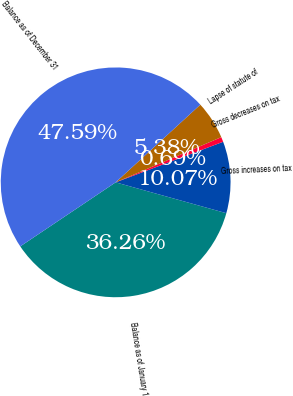<chart> <loc_0><loc_0><loc_500><loc_500><pie_chart><fcel>Balance as of January 1<fcel>Gross increases on tax<fcel>Gross decreases on tax<fcel>Lapse of statute of<fcel>Balance as of December 31<nl><fcel>36.26%<fcel>10.07%<fcel>0.69%<fcel>5.38%<fcel>47.59%<nl></chart> 